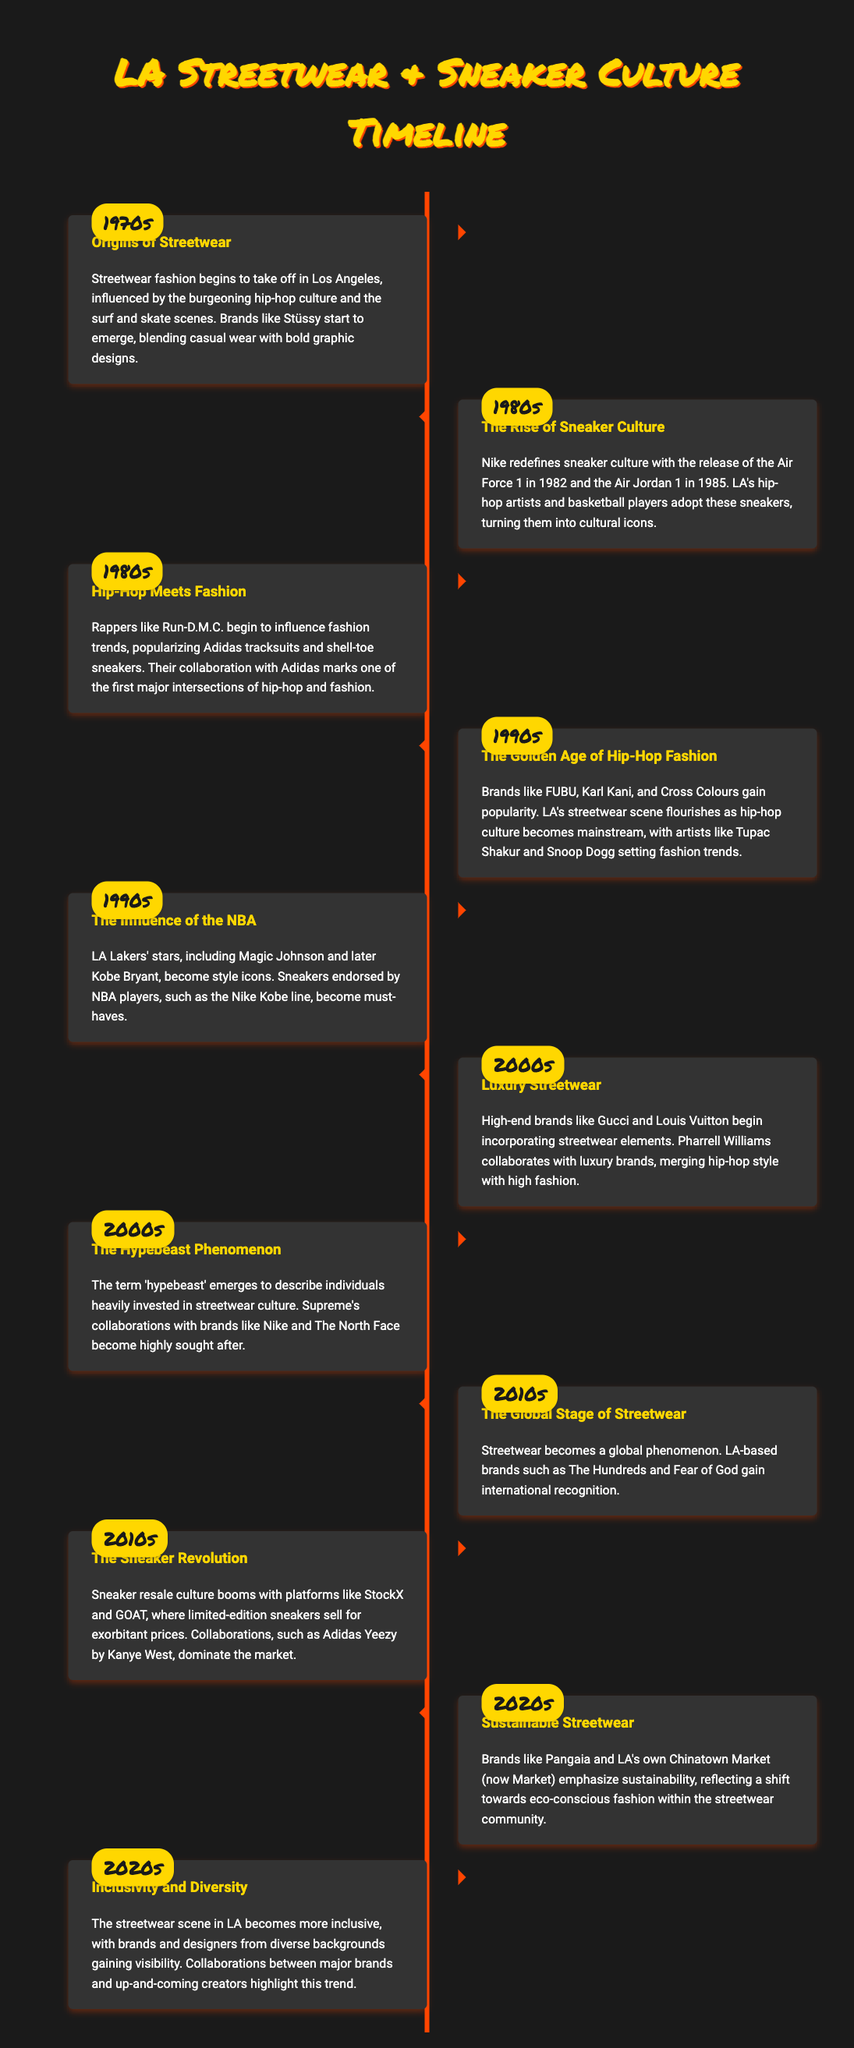what decade saw the origins of streetwear? The origins of streetwear began in the 1970s in Los Angeles.
Answer: 1970s who popularized Adidas tracksuits in the 1980s? Rappers like Run-D.M.C. influenced fashion trends by popularizing Adidas tracksuits.
Answer: Run-D.M.C which hip-hop artist set fashion trends in the 1990s? Tupac Shakur was one of the artists who set fashion trends during the 1990s.
Answer: Tupac Shakur what luxury brands began incorporating streetwear elements in the 2000s? High-end brands like Gucci and Louis Vuitton started merging streetwear with high fashion.
Answer: Gucci and Louis Vuitton what was a major sneaker released in 1985? The Air Jordan 1, released in 1985, became a cultural icon among sneaker collectors.
Answer: Air Jordan 1 which platforms contributed to the sneaker resale culture in the 2010s? Platforms like StockX and GOAT played significant roles in booming sneaker resale culture.
Answer: StockX and GOAT what term describes individuals highly invested in streetwear culture? The term 'hypebeast' emerged to describe individuals heavily invested in streetwear.
Answer: hypebeast how have streetwear brands changed in the 2020s? The streetwear scene has become more inclusive and diverse, with diverse designers gaining visibility.
Answer: Inclusivity and Diversity what major collaborations dominated the sneaker market in the 2010s? Collaborations like Adidas Yeezy by Kanye West dominated the sneaker market in the 2010s.
Answer: Adidas Yeezy 